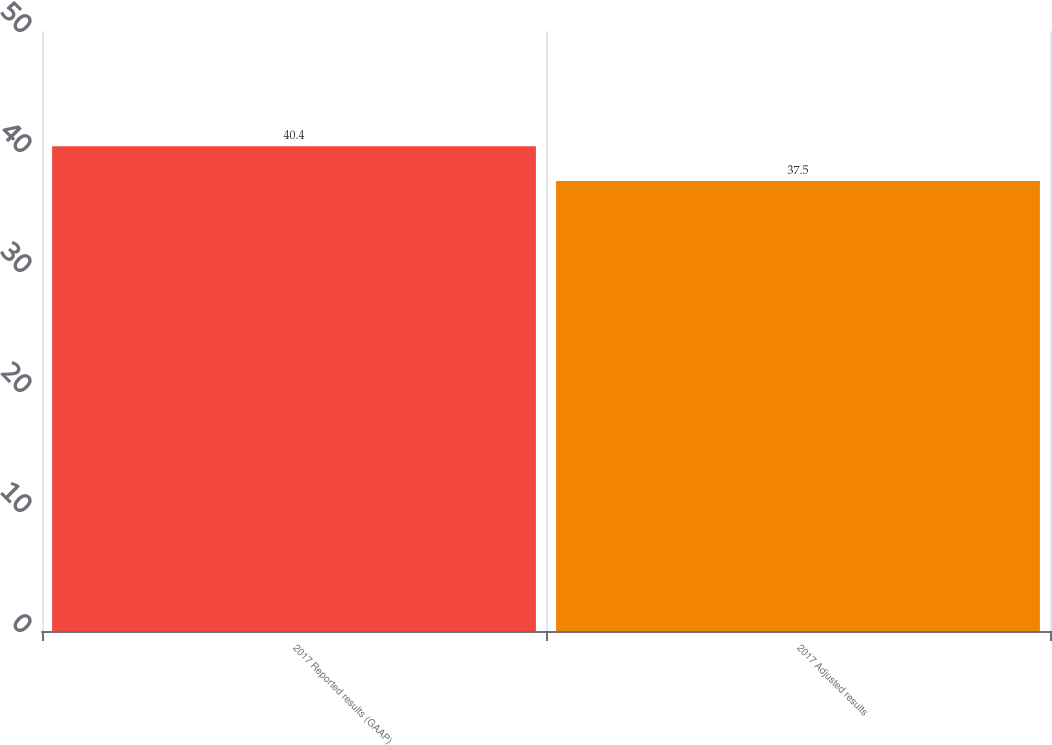Convert chart. <chart><loc_0><loc_0><loc_500><loc_500><bar_chart><fcel>2017 Reported results (GAAP)<fcel>2017 Adjusted results<nl><fcel>40.4<fcel>37.5<nl></chart> 